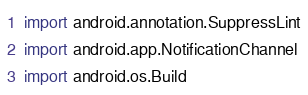Convert code to text. <code><loc_0><loc_0><loc_500><loc_500><_Kotlin_>
import android.annotation.SuppressLint
import android.app.NotificationChannel
import android.os.Build</code> 